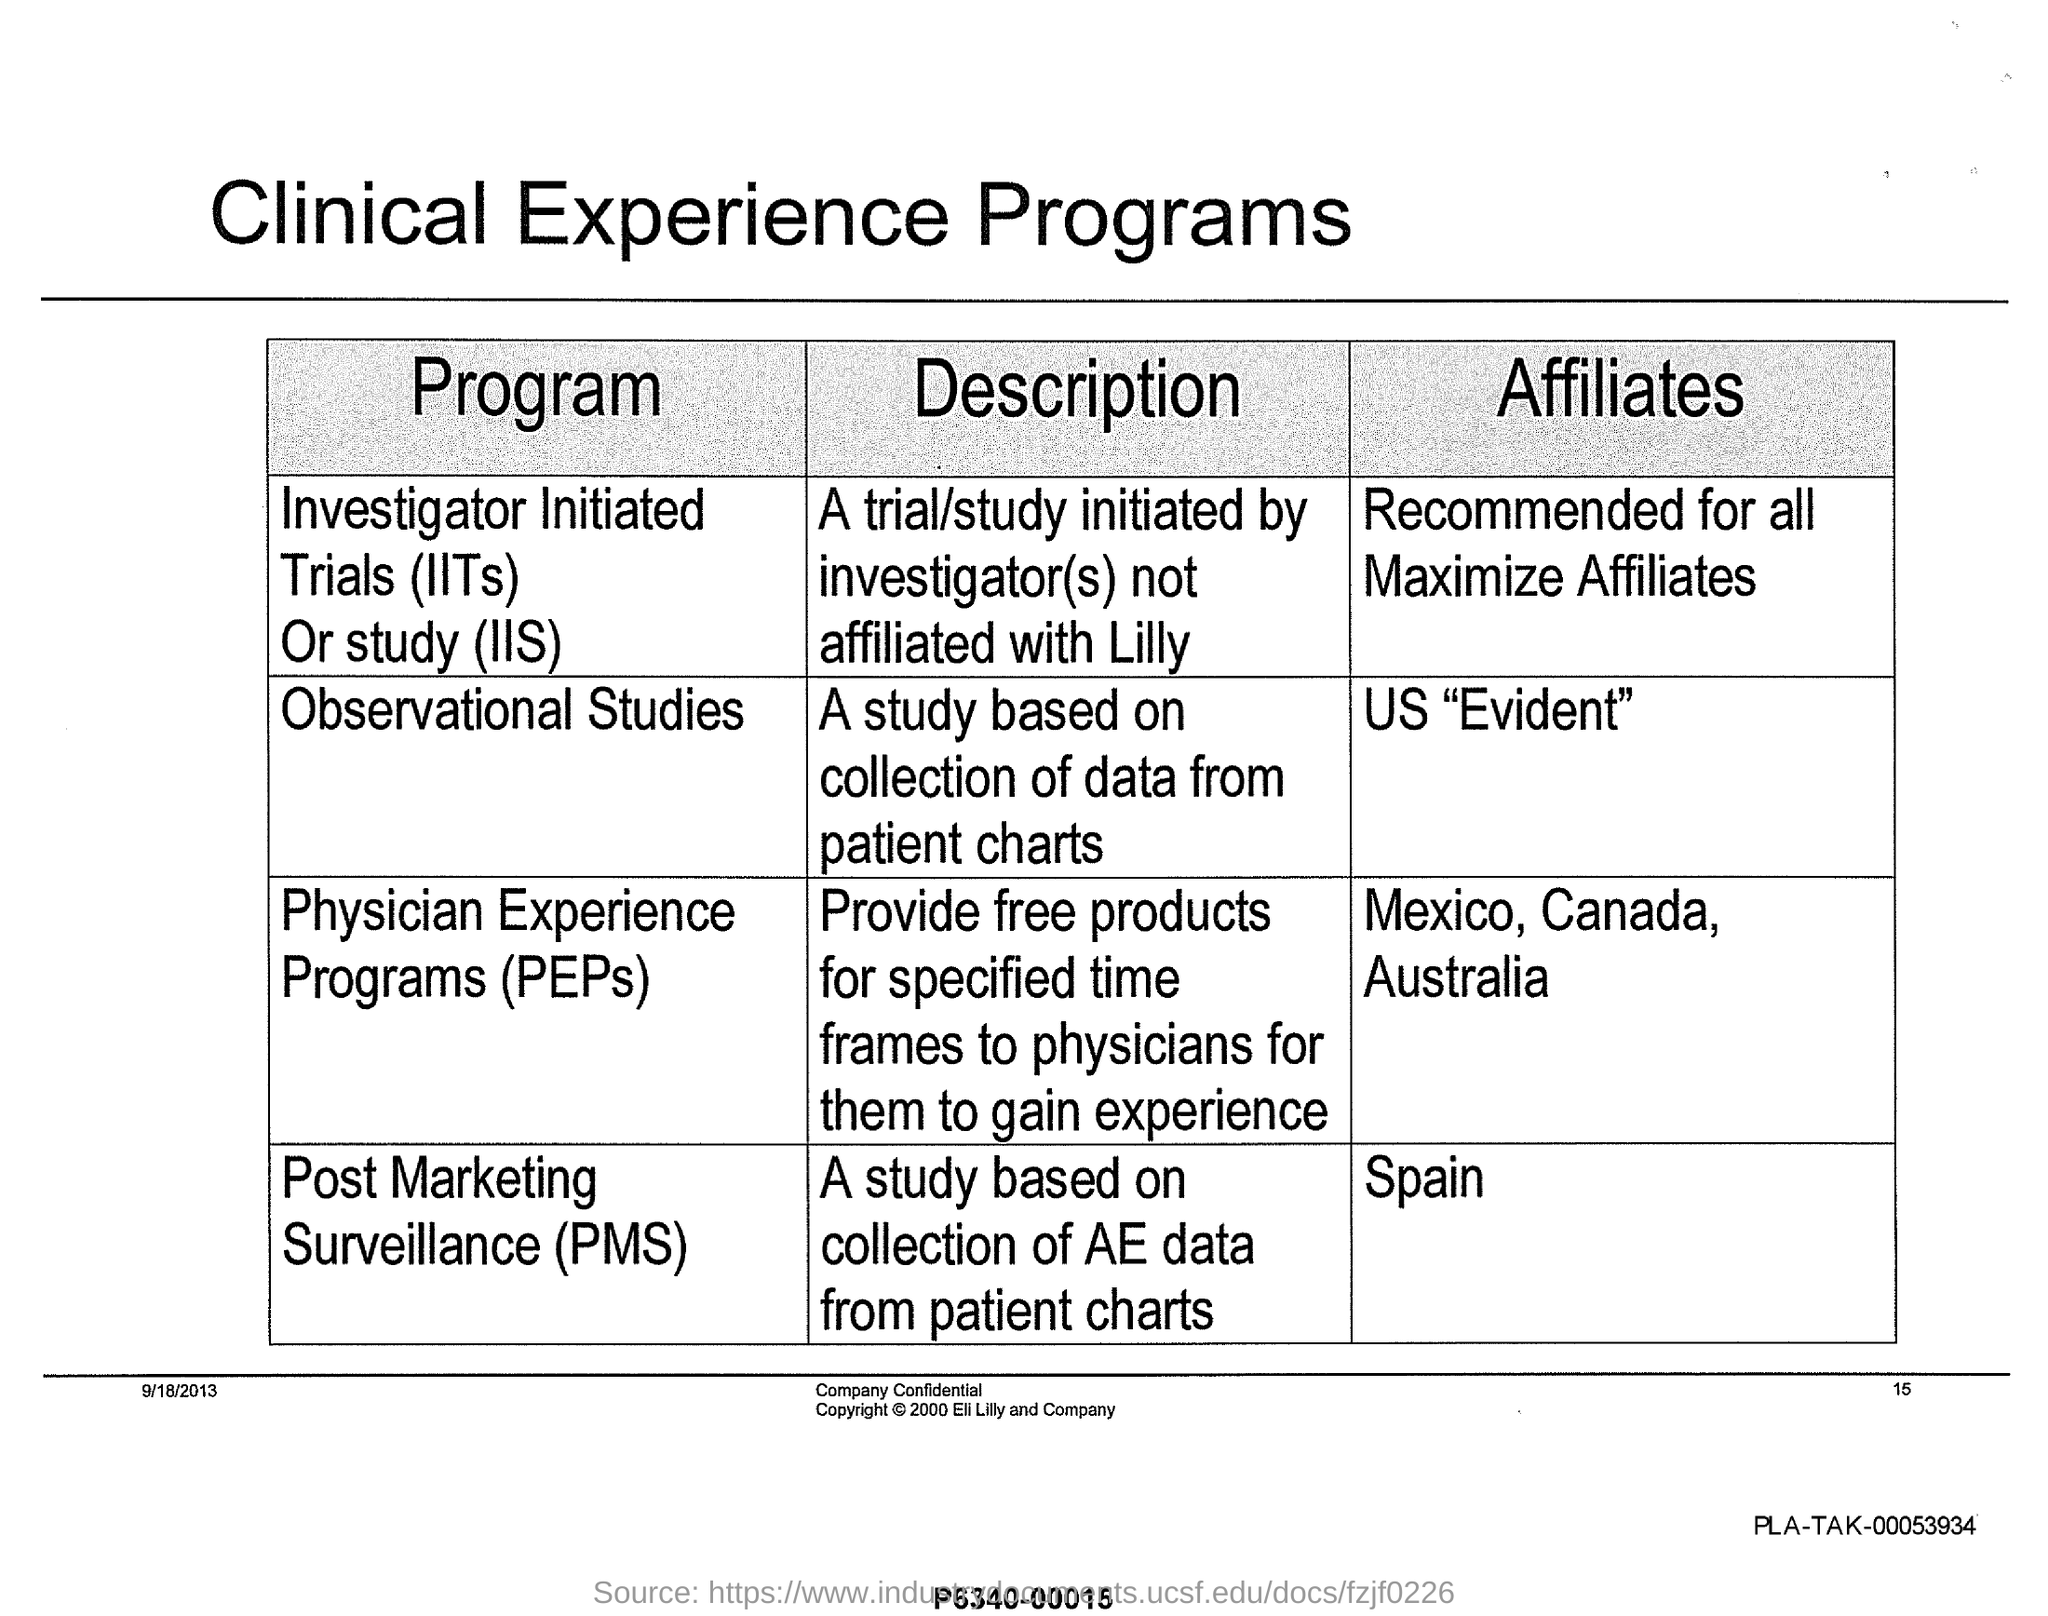Post marketing surveillance(PMS) affiliates to which region?
Provide a succinct answer. Spain. The study based on collection of data from patient charts
Provide a succinct answer. Observational Studies. IITs stands for?
Your answer should be compact. Investigator Initiated Trials. The program which provides free products for specified time frames to physicians to gain experience
Provide a short and direct response. Physician Experience Programs. A study based on collection of AE data from patient charts
Your answer should be very brief. Post Marketing Surveillance (PMS). 